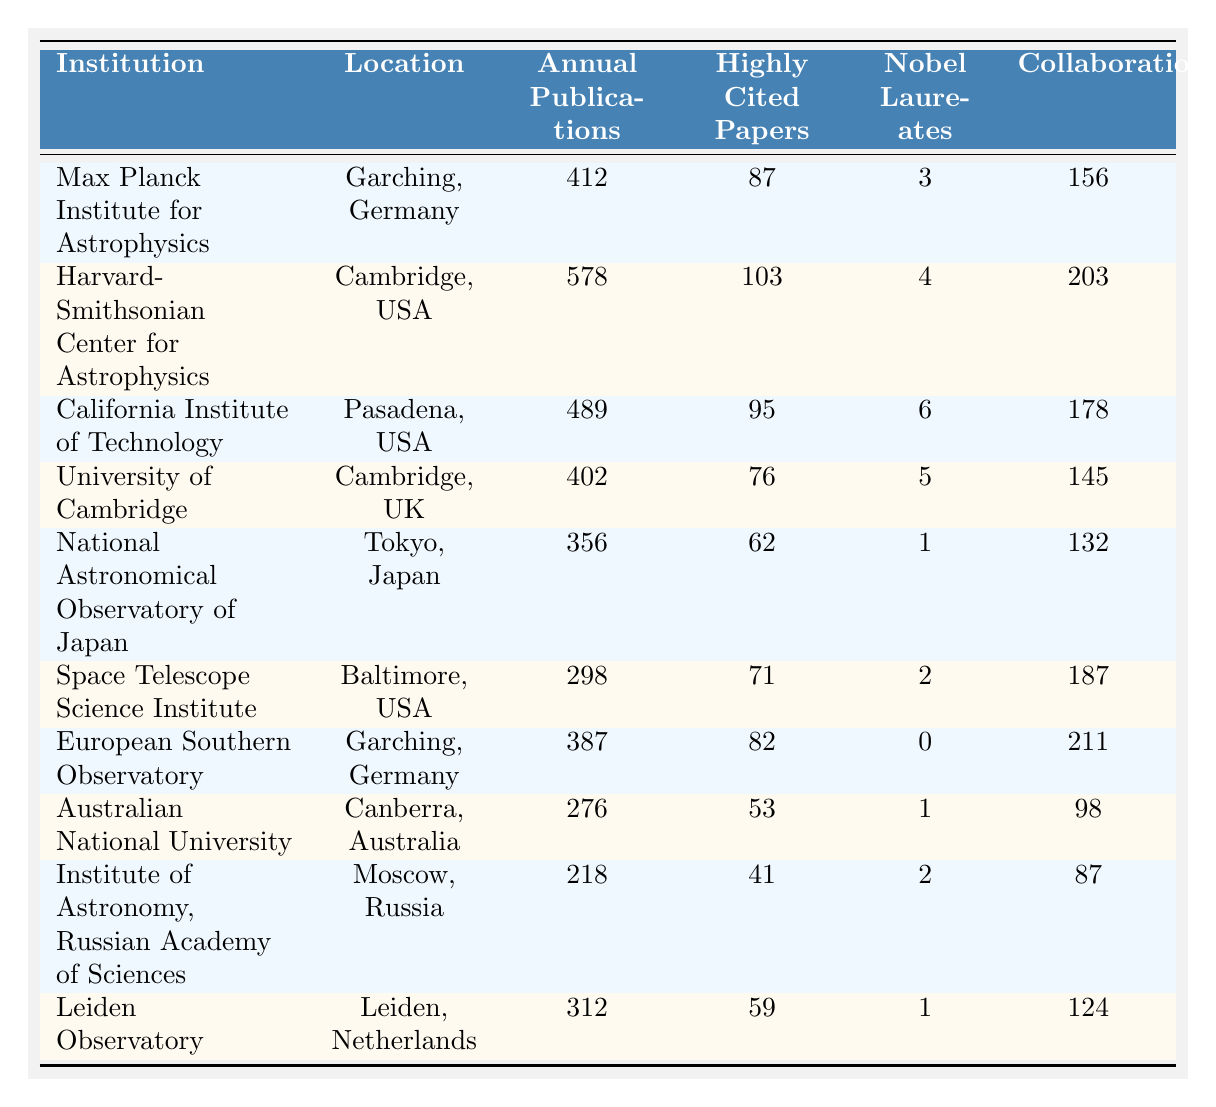What is the location of the California Institute of Technology? The California Institute of Technology is listed in the table, and its location is specified as Pasadena, USA.
Answer: Pasadena, USA Which institution has the highest number of annual publications? By examining the table, the institution with the highest number of annual publications is the Harvard-Smithsonian Center for Astrophysics, which has 578 publications.
Answer: Harvard-Smithsonian Center for Astrophysics How many Nobel Laureates are associated with the Max Planck Institute for Astrophysics? The table shows that the Max Planck Institute for Astrophysics has 3 Nobel Laureates as stated in the corresponding row.
Answer: 3 What is the average number of highly cited papers among the listed institutions? To find the average, we sum the highly cited papers: (87 + 103 + 95 + 76 + 62 + 71 + 82 + 53 + 41 + 59) = 729. There are 10 institutions, so the average is 729 / 10 = 72.9.
Answer: 72.9 Is there any institution with no Nobel Laureates? According to the table, the European Southern Observatory is listed with 0 Nobel Laureates, confirming that there is an institution without any.
Answer: Yes Which institution has the largest number of collaborations? Checking the collaborations column, the European Southern Observatory has the highest number of collaborations at 211.
Answer: European Southern Observatory What is the difference in annual publications between the Harvard-Smithsonian Center for Astrophysics and the Space Telescope Science Institute? The Harvard-Smithsonian Center for Astrophysics has 578 annual publications, while the Space Telescope Science Institute has 298. The difference is 578 - 298 = 280.
Answer: 280 Which institution with Nobel Laureates has the lowest number of collaborations? The Institute of Astronomy, Russian Academy of Sciences has 2 Nobel Laureates and only 87 collaborations, which is the lowest among institutions with Nobel Laureates listed.
Answer: Institute of Astronomy, Russian Academy of Sciences How many institutions have more than 400 annual publications? Referring to the table, the institutions with more than 400 annual publications are the Harvard-Smithsonian Center for Astrophysics, California Institute of Technology, Max Planck Institute for Astrophysics, and European Southern Observatory. There are 4 such institutions.
Answer: 4 What institution has the highest ratio of highly cited papers to annual publications? To find the highest ratio, we calculate the ratio for each institution. Highest ratio is for Harvard-Smithsonian: 103/578 = 0.178, which is higher than any other institution listed.
Answer: Harvard-Smithsonian Center for Astrophysics 